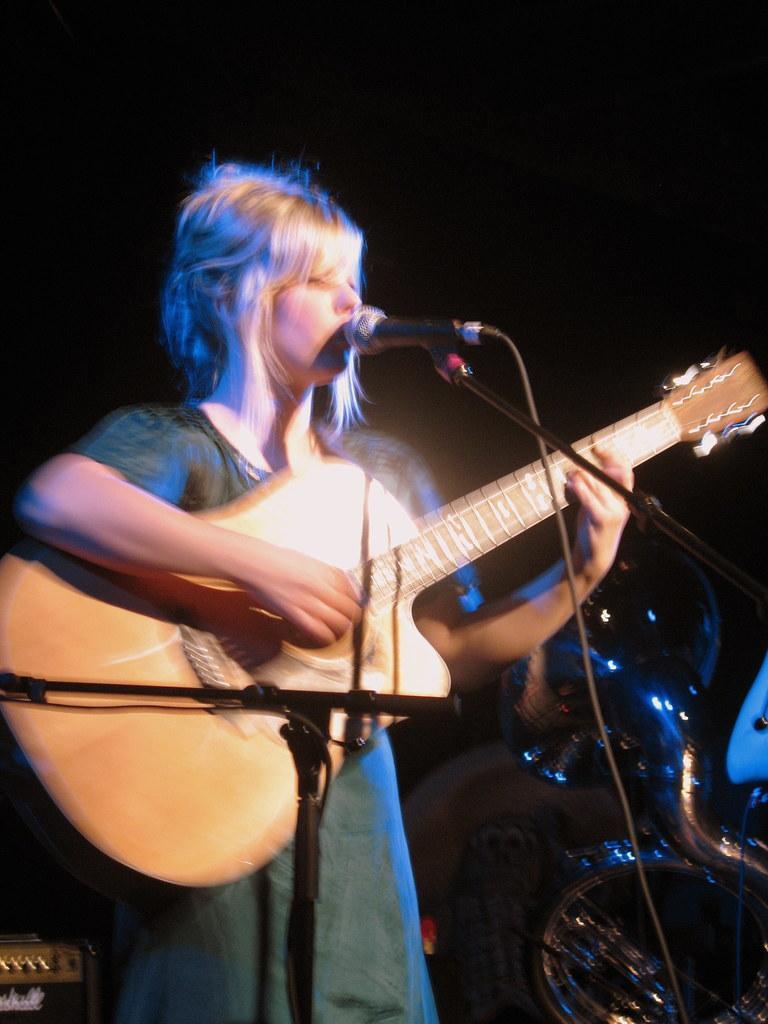Describe this image in one or two sentences. In this image there is a lady playing guitar, in front of her there is a mike, in the background it is dark. 